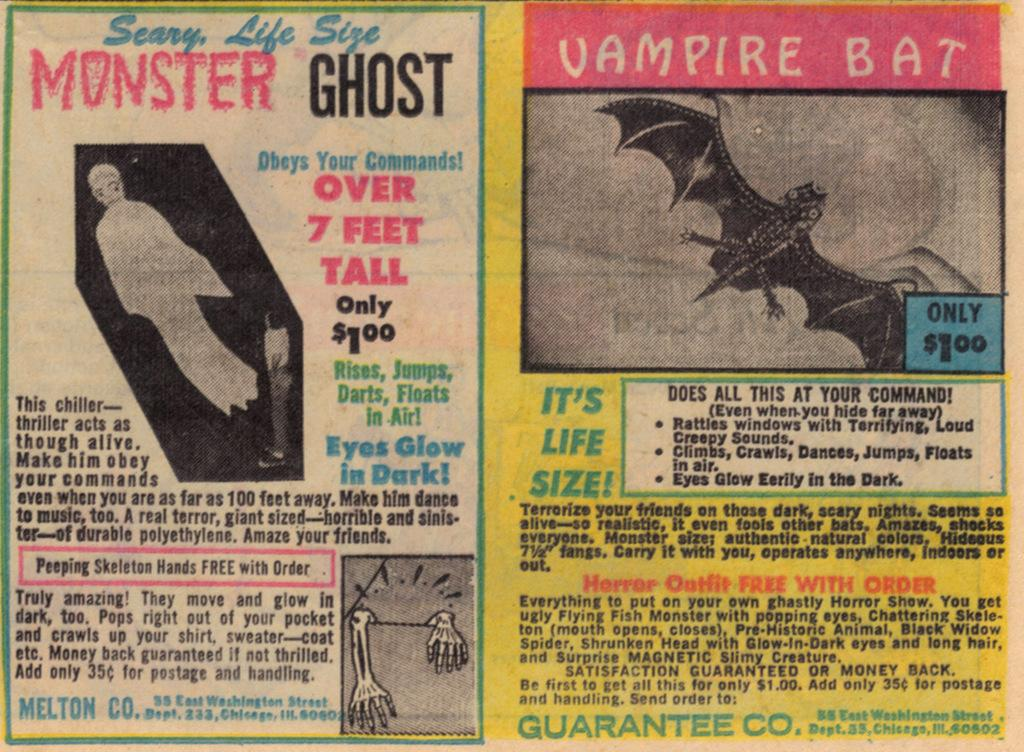<image>
Provide a brief description of the given image. An old newspaper clipping of advertisements for a Scary, Life Size Monster Ghost and a Vampire Bat. 